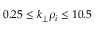<formula> <loc_0><loc_0><loc_500><loc_500>0 . 2 5 \leq k _ { \perp } \rho _ { i } \leq 1 0 . 5</formula> 